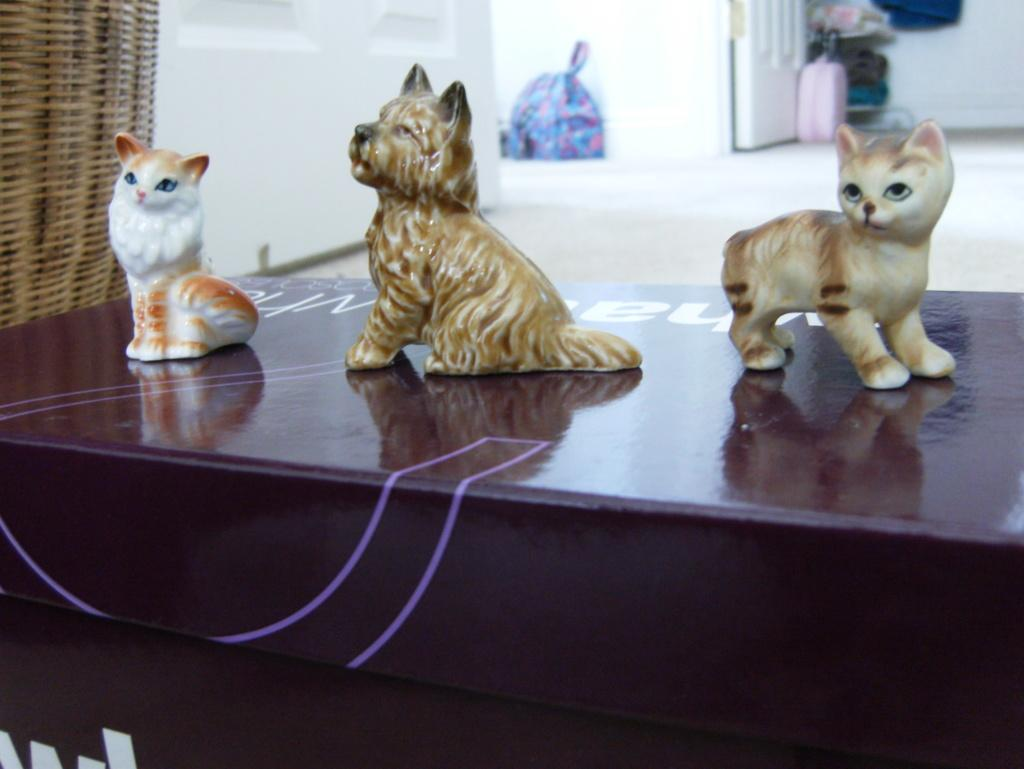How many toys are visible in the image? There are three toys in the image. What colors are the toys? The toys are in white and brown color. Where are the toys located? The toys are on a table. What is the color of the table? The table is in brown and purple color. What can be seen in the background of the image? There is a door in the background of the image. What is the color of the door? The door is in white color. What type of bone is being used as a toy in the image? There is no bone present in the image; the toys are in white and brown color. What team is associated with the toys in the image? There is no team mentioned or associated with the toys in the image. 